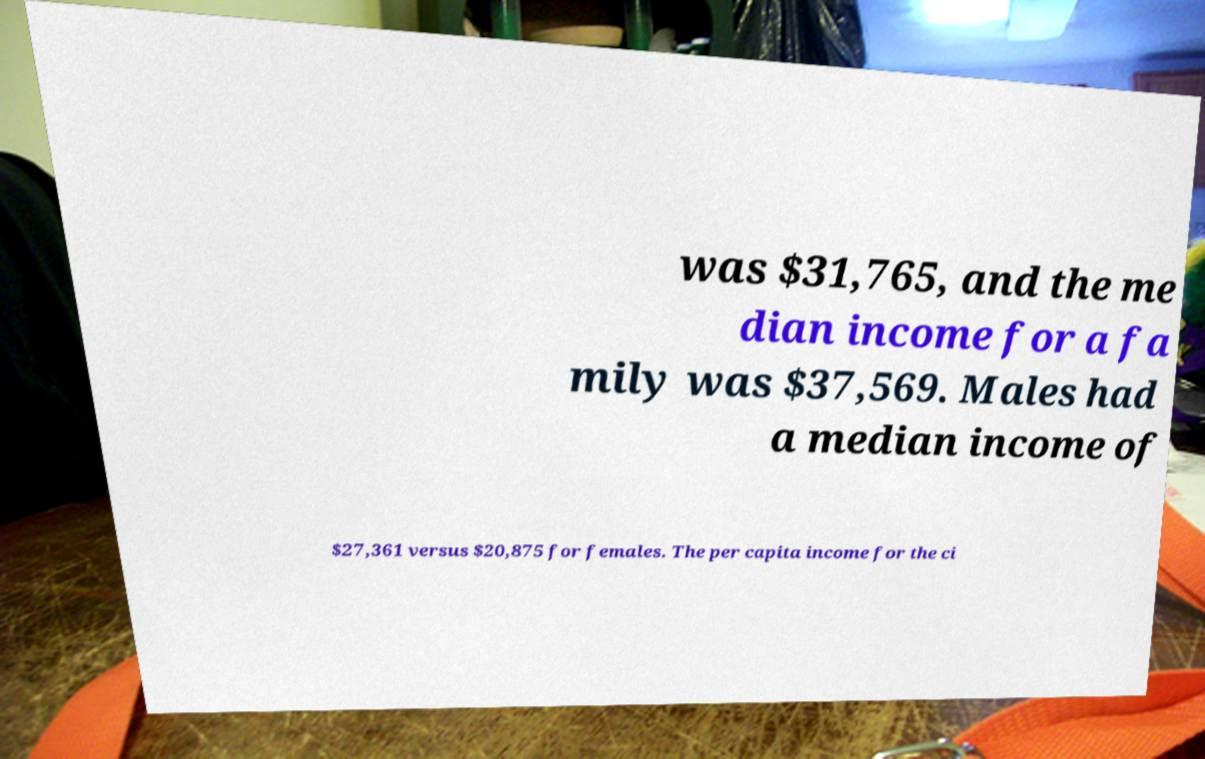There's text embedded in this image that I need extracted. Can you transcribe it verbatim? was $31,765, and the me dian income for a fa mily was $37,569. Males had a median income of $27,361 versus $20,875 for females. The per capita income for the ci 